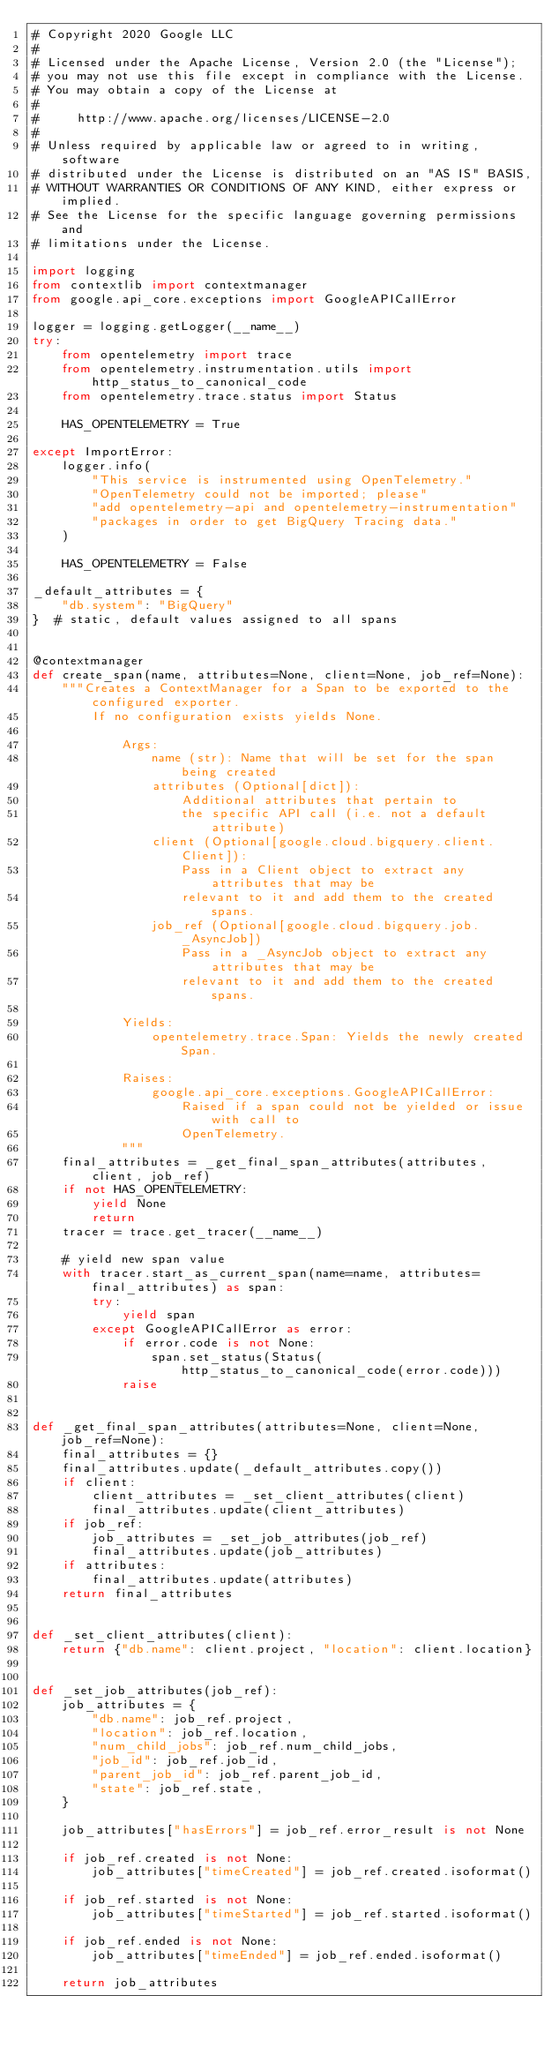<code> <loc_0><loc_0><loc_500><loc_500><_Python_># Copyright 2020 Google LLC
#
# Licensed under the Apache License, Version 2.0 (the "License");
# you may not use this file except in compliance with the License.
# You may obtain a copy of the License at
#
#     http://www.apache.org/licenses/LICENSE-2.0
#
# Unless required by applicable law or agreed to in writing, software
# distributed under the License is distributed on an "AS IS" BASIS,
# WITHOUT WARRANTIES OR CONDITIONS OF ANY KIND, either express or implied.
# See the License for the specific language governing permissions and
# limitations under the License.

import logging
from contextlib import contextmanager
from google.api_core.exceptions import GoogleAPICallError

logger = logging.getLogger(__name__)
try:
    from opentelemetry import trace
    from opentelemetry.instrumentation.utils import http_status_to_canonical_code
    from opentelemetry.trace.status import Status

    HAS_OPENTELEMETRY = True

except ImportError:
    logger.info(
        "This service is instrumented using OpenTelemetry."
        "OpenTelemetry could not be imported; please"
        "add opentelemetry-api and opentelemetry-instrumentation"
        "packages in order to get BigQuery Tracing data."
    )

    HAS_OPENTELEMETRY = False

_default_attributes = {
    "db.system": "BigQuery"
}  # static, default values assigned to all spans


@contextmanager
def create_span(name, attributes=None, client=None, job_ref=None):
    """Creates a ContextManager for a Span to be exported to the configured exporter.
        If no configuration exists yields None.

            Args:
                name (str): Name that will be set for the span being created
                attributes (Optional[dict]):
                    Additional attributes that pertain to
                    the specific API call (i.e. not a default attribute)
                client (Optional[google.cloud.bigquery.client.Client]):
                    Pass in a Client object to extract any attributes that may be
                    relevant to it and add them to the created spans.
                job_ref (Optional[google.cloud.bigquery.job._AsyncJob])
                    Pass in a _AsyncJob object to extract any attributes that may be
                    relevant to it and add them to the created spans.

            Yields:
                opentelemetry.trace.Span: Yields the newly created Span.

            Raises:
                google.api_core.exceptions.GoogleAPICallError:
                    Raised if a span could not be yielded or issue with call to
                    OpenTelemetry.
            """
    final_attributes = _get_final_span_attributes(attributes, client, job_ref)
    if not HAS_OPENTELEMETRY:
        yield None
        return
    tracer = trace.get_tracer(__name__)

    # yield new span value
    with tracer.start_as_current_span(name=name, attributes=final_attributes) as span:
        try:
            yield span
        except GoogleAPICallError as error:
            if error.code is not None:
                span.set_status(Status(http_status_to_canonical_code(error.code)))
            raise


def _get_final_span_attributes(attributes=None, client=None, job_ref=None):
    final_attributes = {}
    final_attributes.update(_default_attributes.copy())
    if client:
        client_attributes = _set_client_attributes(client)
        final_attributes.update(client_attributes)
    if job_ref:
        job_attributes = _set_job_attributes(job_ref)
        final_attributes.update(job_attributes)
    if attributes:
        final_attributes.update(attributes)
    return final_attributes


def _set_client_attributes(client):
    return {"db.name": client.project, "location": client.location}


def _set_job_attributes(job_ref):
    job_attributes = {
        "db.name": job_ref.project,
        "location": job_ref.location,
        "num_child_jobs": job_ref.num_child_jobs,
        "job_id": job_ref.job_id,
        "parent_job_id": job_ref.parent_job_id,
        "state": job_ref.state,
    }

    job_attributes["hasErrors"] = job_ref.error_result is not None

    if job_ref.created is not None:
        job_attributes["timeCreated"] = job_ref.created.isoformat()

    if job_ref.started is not None:
        job_attributes["timeStarted"] = job_ref.started.isoformat()

    if job_ref.ended is not None:
        job_attributes["timeEnded"] = job_ref.ended.isoformat()

    return job_attributes
</code> 